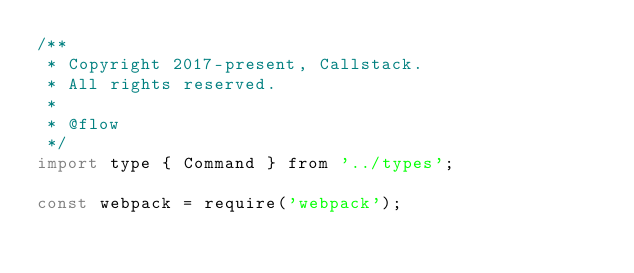<code> <loc_0><loc_0><loc_500><loc_500><_JavaScript_>/**
 * Copyright 2017-present, Callstack.
 * All rights reserved.
 *
 * @flow
 */
import type { Command } from '../types';

const webpack = require('webpack');</code> 